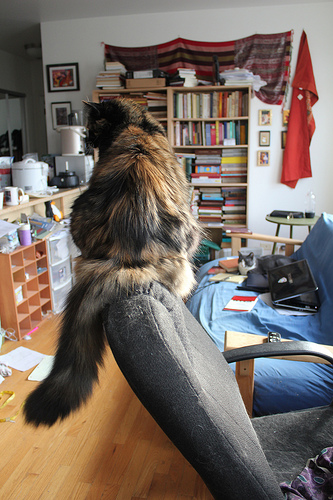<image>
Can you confirm if the cat is in front of the book? Yes. The cat is positioned in front of the book, appearing closer to the camera viewpoint. 